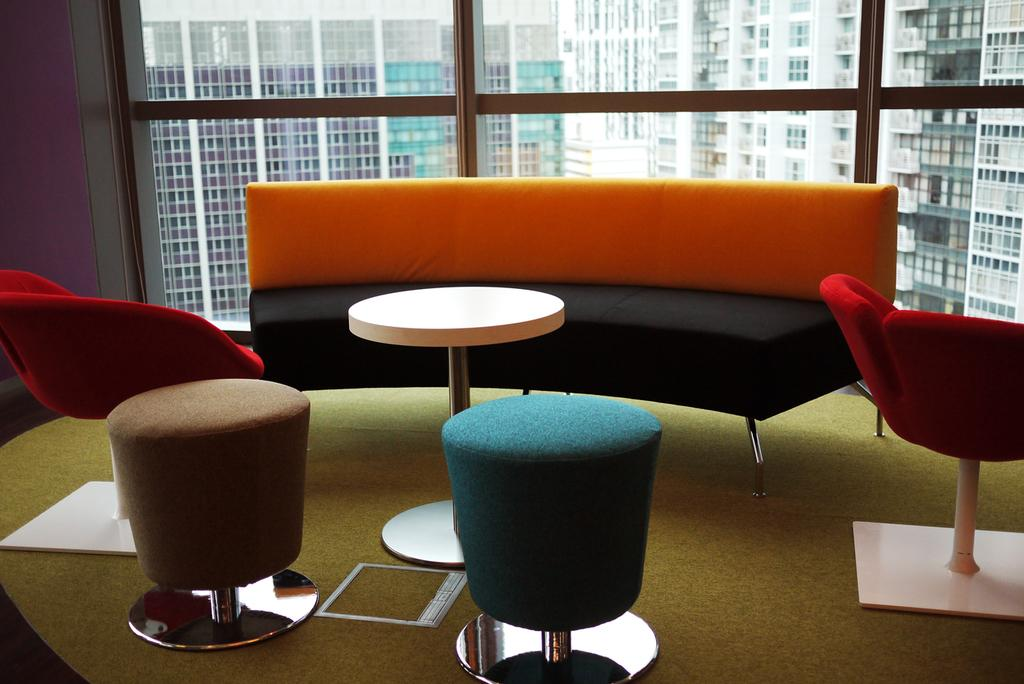What type of furniture is present in the image? There is a sofa and chairs in the image. What can be seen in the background of the image? There are buildings in the background of the image. How many bikes are parked next to the sofa in the image? There are no bikes present in the image. What type of sign can be seen hanging on the wall in the image? There is no sign visible in the image. What is the nature of the love depicted in the image? There is no depiction of love in the image; it features a sofa, chairs, and buildings in the background. 